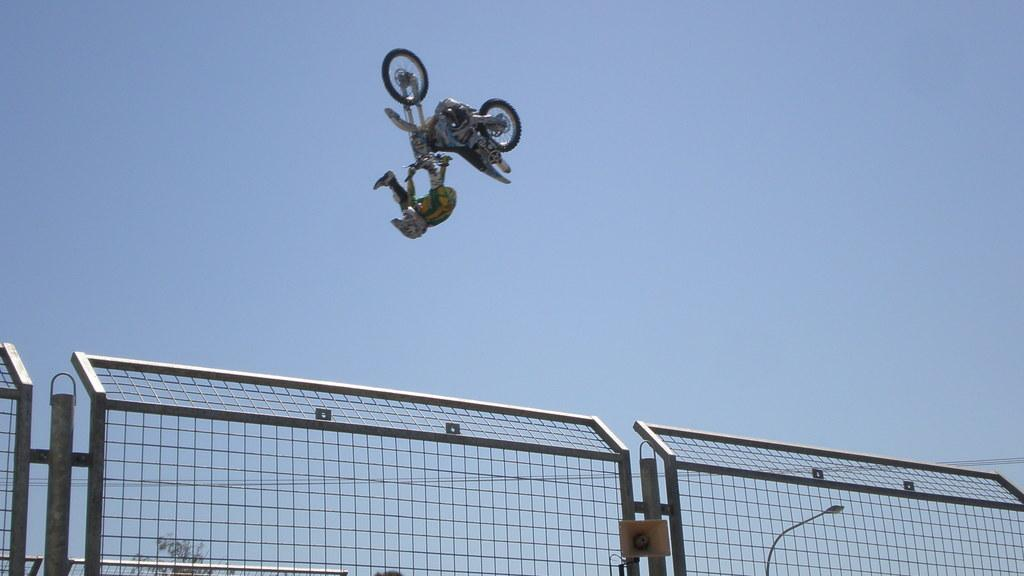What is happening in the image involving a person? The person is jumping along with a motorbike in the image. What objects can be seen in the image besides the person and motorbike? There is a fence, a megaphone, a pole, a light, and a tree in the image. What is the background of the image? The sky is visible in the background of the image. Can you see any boats in the harbor in the image? There is no harbor or boats present in the image. What does the person in the image hope to achieve by jumping along with the motorbike? The image does not provide any information about the person's hopes or intentions, so we cannot answer this question. 